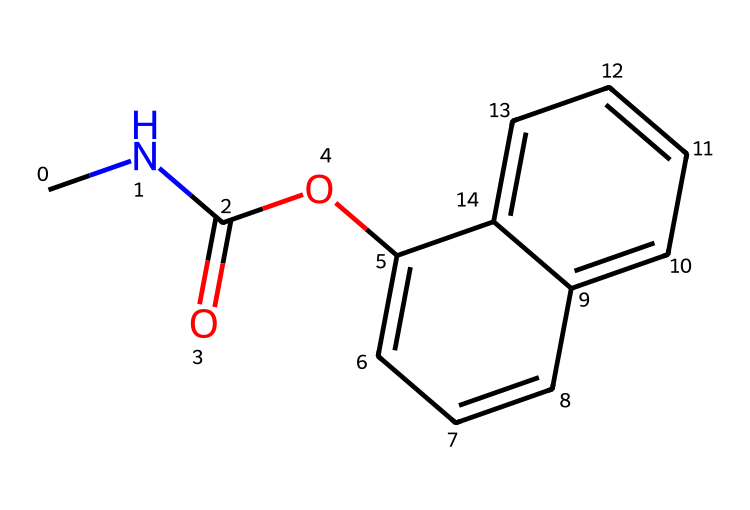What is the IUPAC name of this chemical? The structure provided corresponds to carbaryl. The IUPAC name is derived from the functional groups and the arrangement of atoms in the structure. Here, the amine (CNC) and the carbamate (C(=O)O) parts lead to the name carbaryl.
Answer: carbaryl How many carbon atoms are in this molecule? To count the carbon atoms, we look for all occurrences of the carbon "C" in the SMILES, including those in the rings and in the functional groups. The total count reveals there are 11 carbon atoms in the structure.
Answer: 11 What functional group is present in carbaryl? In the provided structure, we identify the functional groups present. The carbonyl (C=O) and the ether (C-O-C) functional groups indicate that this molecule is a carbamate. Thus, the specific functional group identified here is a carbamate.
Answer: carbamate How many rings are there in the structure of carbaryl? Analyzing the molecular structure, we can see that there are two interconnected rings formed by cyclical arrangements of the carbon atoms. These rings are characteristic of the naphthalene part of the molecule. Hence, there are 2 rings present.
Answer: 2 What type of pesticide is carbaryl classified as? Carbaryl is classified as a carbamate pesticide. This classification is based on its mechanism of action, which involves inhibiting the enzyme acetylcholinesterase, a characteristic action of carbamate insecticides.
Answer: carbamate What is the molecular weight of carbaryl? To find the molecular weight, we can calculate the total atomic mass of the atoms represented in the SMILES structure. The total molecular weight for carbaryl is approximately 201.24 g/mol, based on the sum of atomic masses for each element in the formula.
Answer: 201.24 g/mol 